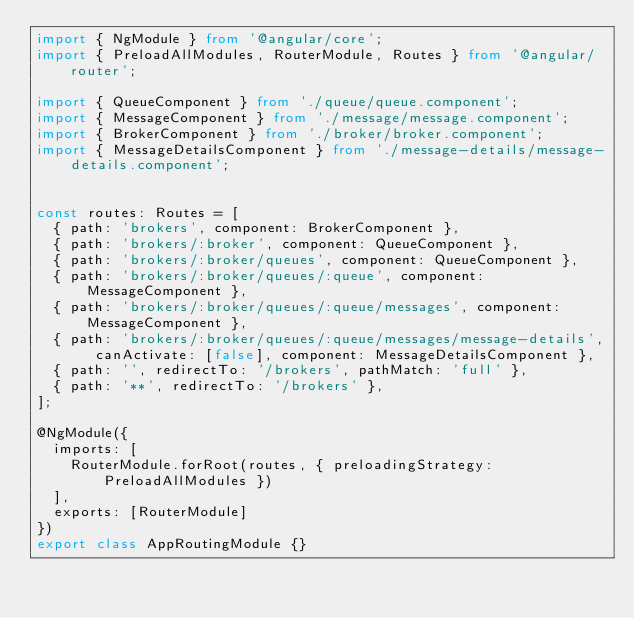<code> <loc_0><loc_0><loc_500><loc_500><_TypeScript_>import { NgModule } from '@angular/core';
import { PreloadAllModules, RouterModule, Routes } from '@angular/router';

import { QueueComponent } from './queue/queue.component';
import { MessageComponent } from './message/message.component';
import { BrokerComponent } from './broker/broker.component';
import { MessageDetailsComponent } from './message-details/message-details.component';


const routes: Routes = [
  { path: 'brokers', component: BrokerComponent },
  { path: 'brokers/:broker', component: QueueComponent },
  { path: 'brokers/:broker/queues', component: QueueComponent },
  { path: 'brokers/:broker/queues/:queue', component: MessageComponent },
  { path: 'brokers/:broker/queues/:queue/messages', component: MessageComponent },
  { path: 'brokers/:broker/queues/:queue/messages/message-details', canActivate: [false], component: MessageDetailsComponent },
  { path: '', redirectTo: '/brokers', pathMatch: 'full' },
  { path: '**', redirectTo: '/brokers' },
];

@NgModule({
  imports: [
    RouterModule.forRoot(routes, { preloadingStrategy: PreloadAllModules })
  ],
  exports: [RouterModule]
})
export class AppRoutingModule {}
</code> 